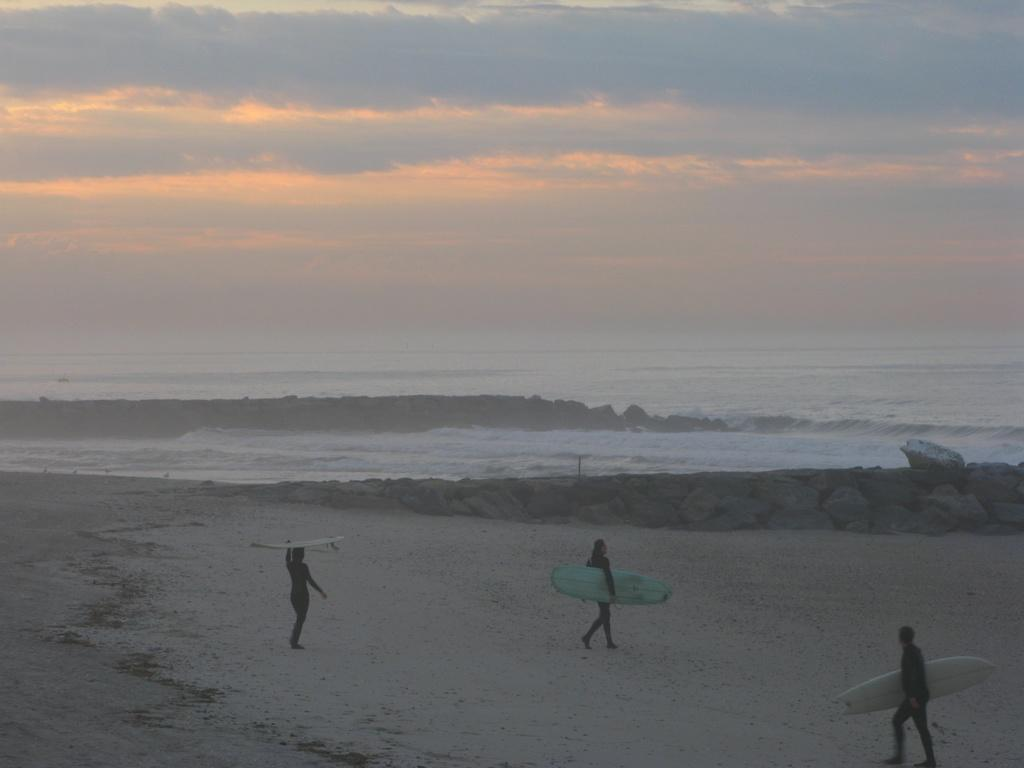How many people are in the image? There are three persons in the image. What are the persons doing in the image? The persons are walking in the sand and holding surfboards. What is the background of the image? There is a beach in the background of the image. What is visible at the top of the image? The sky is visible at the top of the image. What type of comparison can be made between the persons and a bat in the image? There is no bat present in the image, so no comparison can be made between the persons and a bat. 